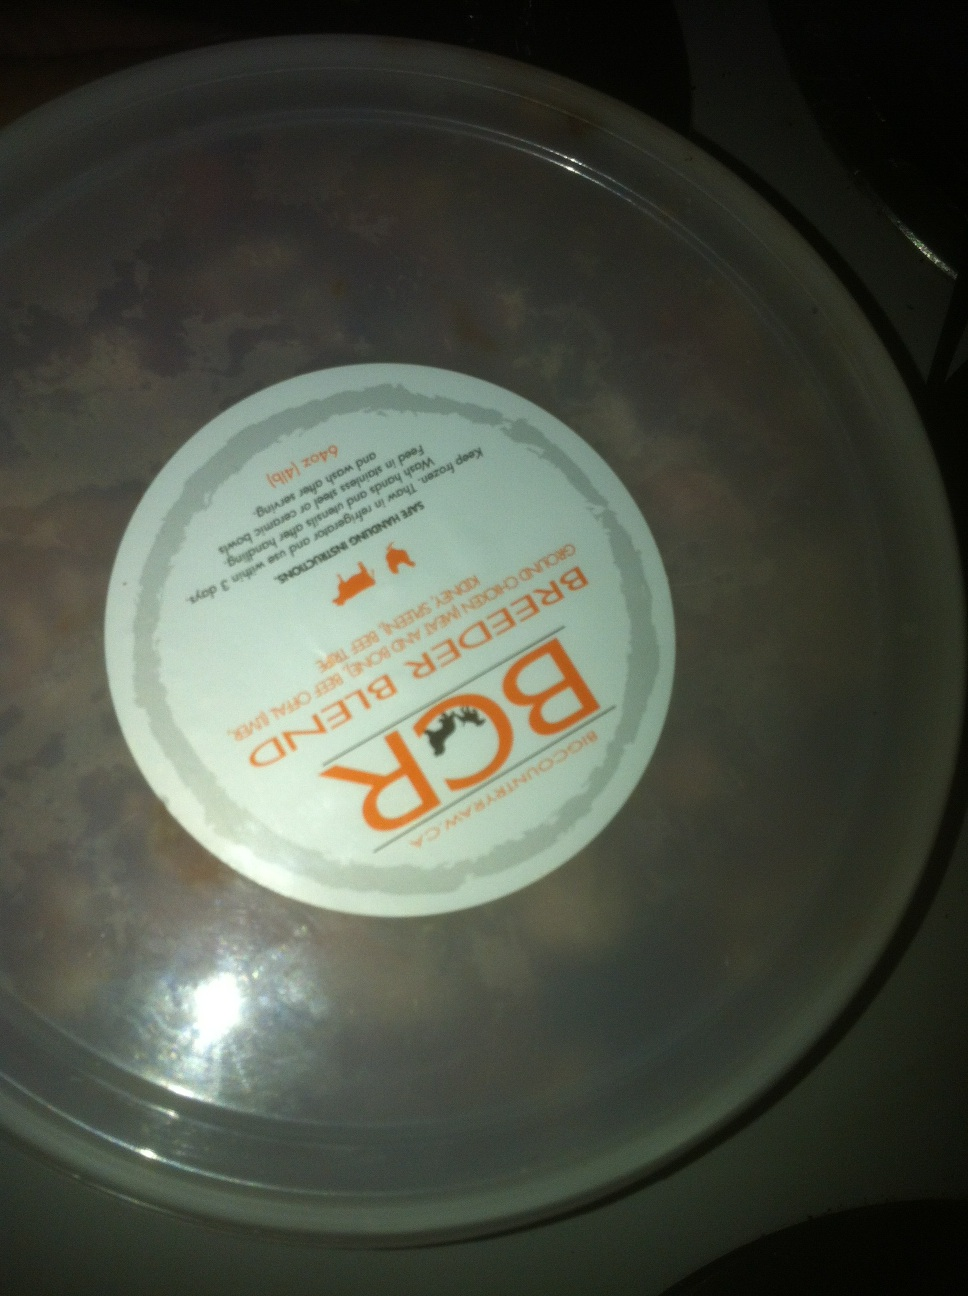Does the label indicate this product is for humans or pets? While the complete text is not entirely clear, the presence of an animal icon and the words 'Beef Dinner' often associate the product with pet food. To confirm, one would ideally look for specific indicators such as 'dog' or 'cat' food, or related terms like 'formula', 'feed', or 'nutrition' typically found on pet food packaging.  Is there anything I need to be aware of before feeding this product to my pet? It's important to read the label thoroughly for feeding instructions and nutritional content to ensure it's suitable for your pet's dietary needs. Additionally, checking the expiry date and any special storage instructions would be essential for your pet's health. If the label is not clear, it's best to seek a clearer image or consult the product directly. 